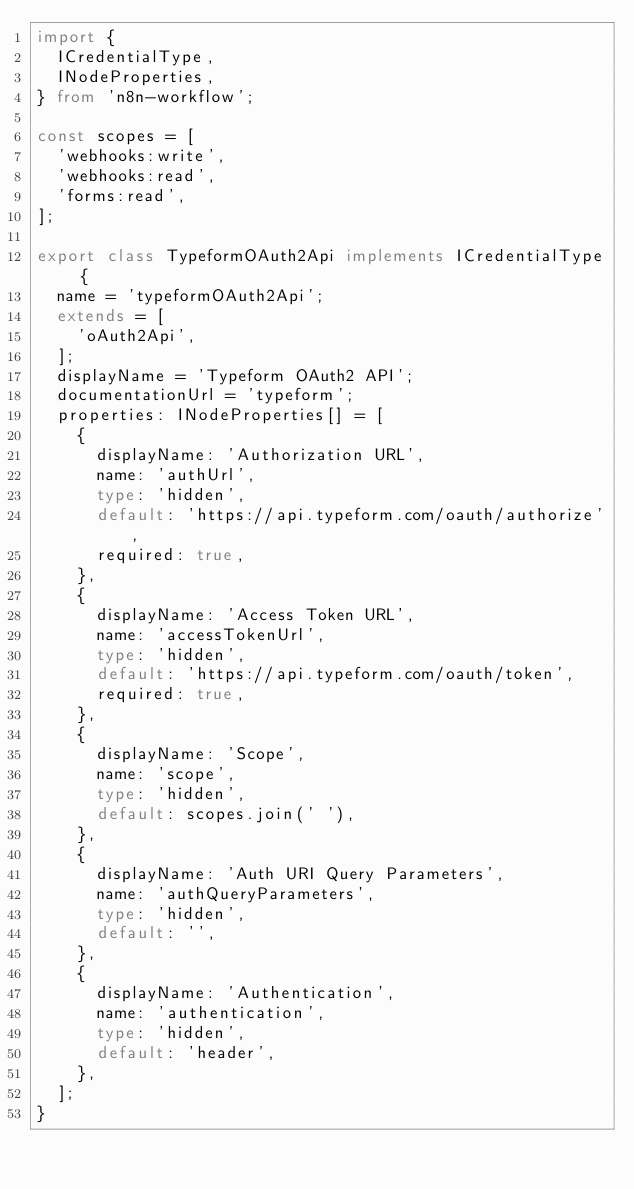Convert code to text. <code><loc_0><loc_0><loc_500><loc_500><_TypeScript_>import {
	ICredentialType,
	INodeProperties,
} from 'n8n-workflow';

const scopes = [
	'webhooks:write',
	'webhooks:read',
	'forms:read',
];

export class TypeformOAuth2Api implements ICredentialType {
	name = 'typeformOAuth2Api';
	extends = [
		'oAuth2Api',
	];
	displayName = 'Typeform OAuth2 API';
	documentationUrl = 'typeform';
	properties: INodeProperties[] = [
		{
			displayName: 'Authorization URL',
			name: 'authUrl',
			type: 'hidden',
			default: 'https://api.typeform.com/oauth/authorize',
			required: true,
		},
		{
			displayName: 'Access Token URL',
			name: 'accessTokenUrl',
			type: 'hidden',
			default: 'https://api.typeform.com/oauth/token',
			required: true,
		},
		{
			displayName: 'Scope',
			name: 'scope',
			type: 'hidden',
			default: scopes.join(' '),
		},
		{
			displayName: 'Auth URI Query Parameters',
			name: 'authQueryParameters',
			type: 'hidden',
			default: '',
		},
		{
			displayName: 'Authentication',
			name: 'authentication',
			type: 'hidden',
			default: 'header',
		},
	];
}
</code> 